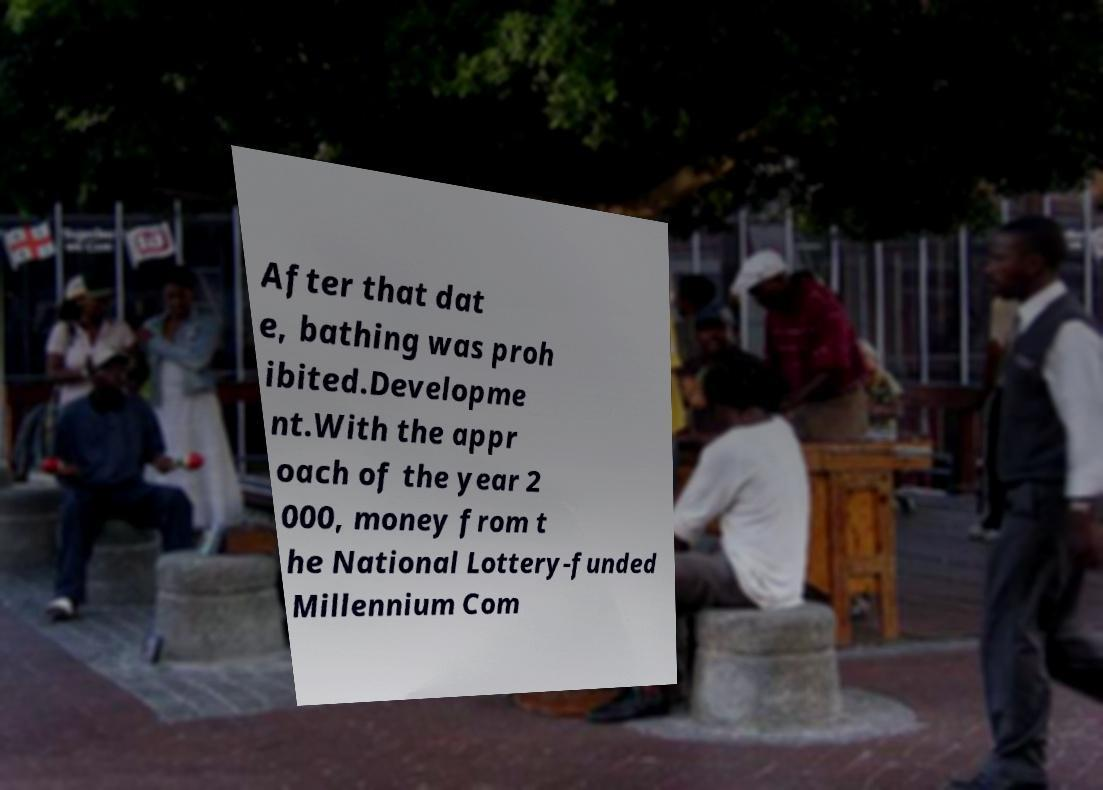Please read and relay the text visible in this image. What does it say? After that dat e, bathing was proh ibited.Developme nt.With the appr oach of the year 2 000, money from t he National Lottery-funded Millennium Com 